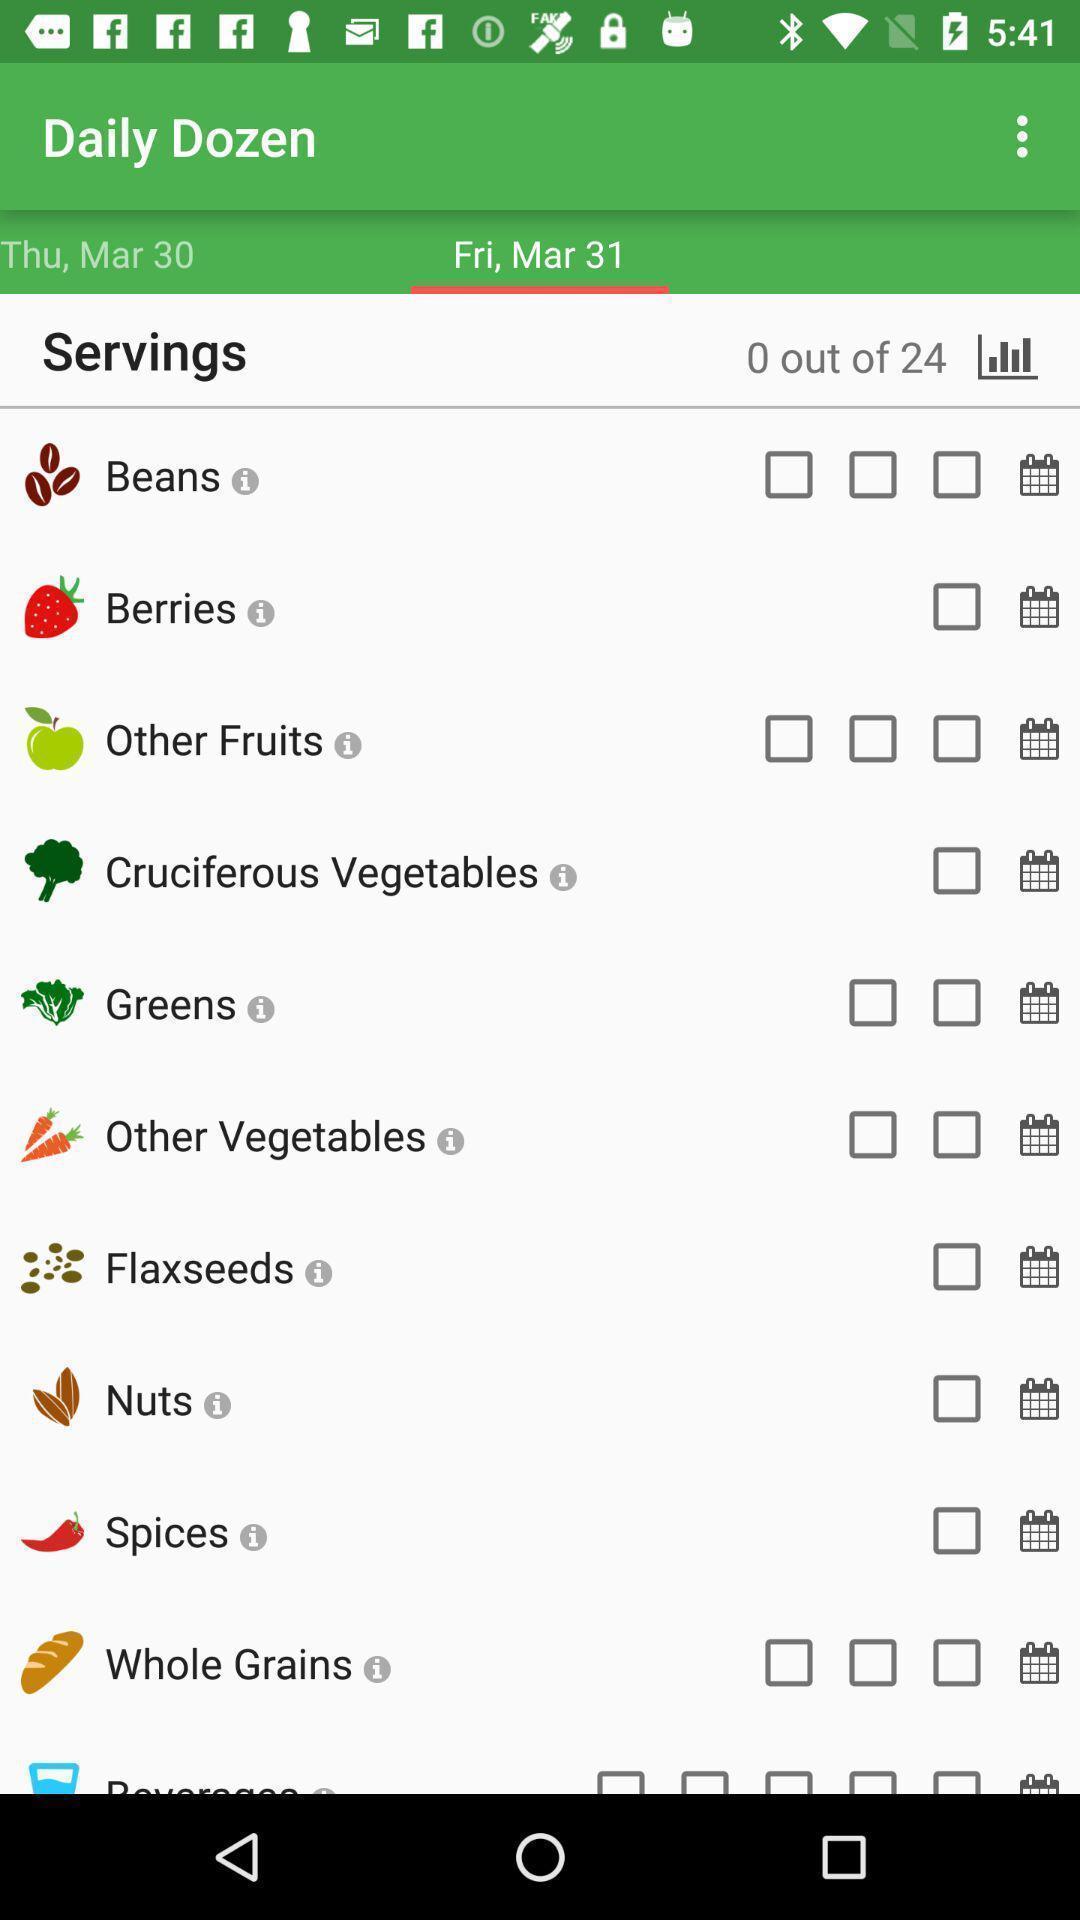Tell me what you see in this picture. Screen displaying multiple food options with pictures. 